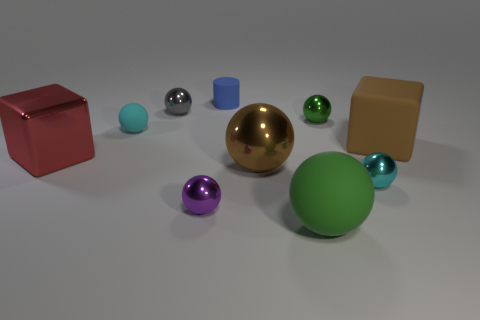There is a cyan thing to the right of the cyan object that is behind the cyan metallic sphere that is in front of the large brown metal sphere; what is its size?
Give a very brief answer. Small. There is a big brown object on the left side of the cyan shiny ball; does it have the same shape as the big brown object that is behind the big red thing?
Offer a very short reply. No. What is the size of the cyan shiny thing that is the same shape as the purple shiny object?
Provide a succinct answer. Small. How many tiny spheres are made of the same material as the big red object?
Your answer should be compact. 4. What material is the blue cylinder?
Offer a very short reply. Rubber. What shape is the brown thing right of the cyan thing in front of the large brown rubber thing?
Offer a very short reply. Cube. There is a small cyan object in front of the large red block; what shape is it?
Your response must be concise. Sphere. How many small metal spheres have the same color as the large matte ball?
Offer a very short reply. 1. The big metallic sphere has what color?
Give a very brief answer. Brown. How many small green balls are to the left of the large block to the right of the cyan rubber thing?
Provide a succinct answer. 1. 